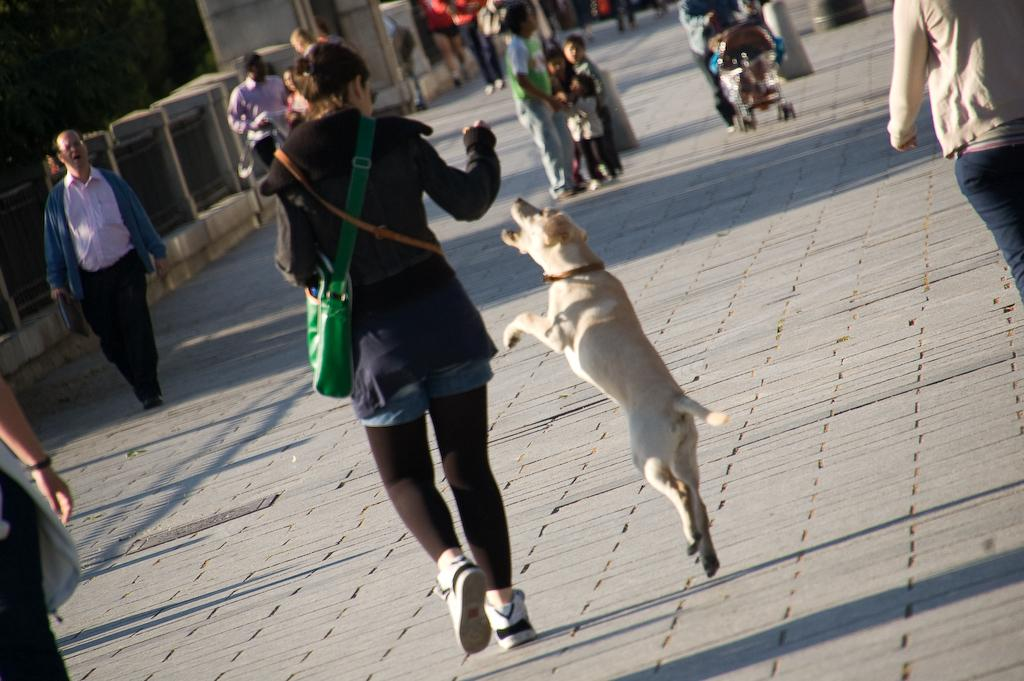What are the people in the image doing? The people in the image are walking on the road. What animal can be seen in the image? There is a dog in the image. What is located on the left side of the image? There are trees and a fence on the left side of the image. How many sisters are walking together in the image? There is no mention of sisters in the image, so we cannot determine the number of sisters present. Is there a chain visible in the image? There is no chain present in the image. 